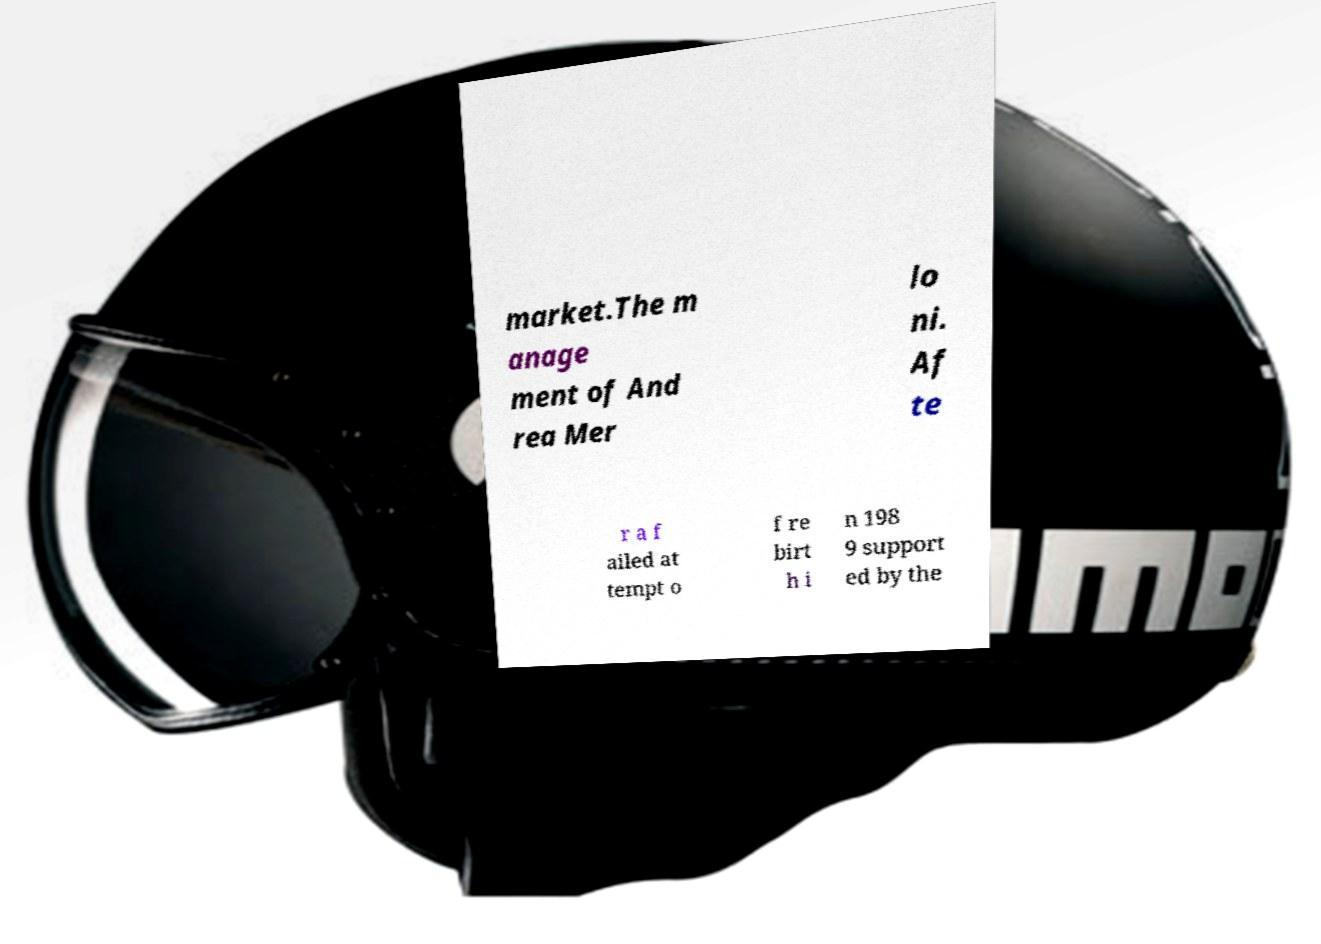Could you assist in decoding the text presented in this image and type it out clearly? market.The m anage ment of And rea Mer lo ni. Af te r a f ailed at tempt o f re birt h i n 198 9 support ed by the 